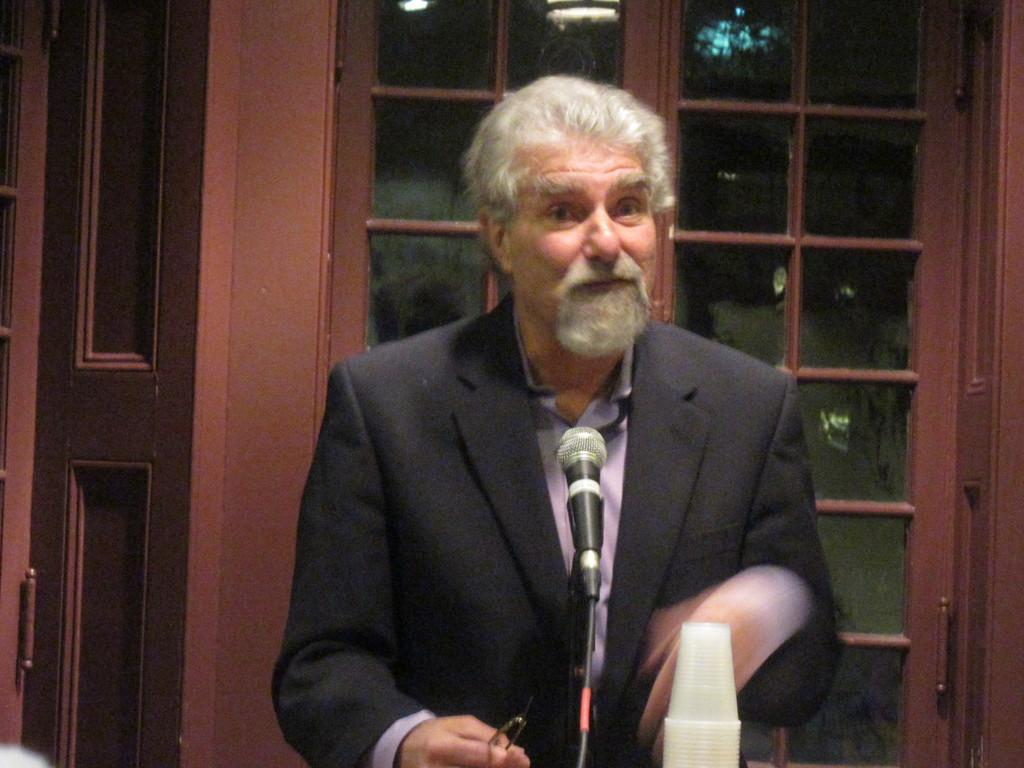Who is present in the image? There is a man in the image. What is the man doing in the image? The man is standing near a microphone. What can be seen in the background of the image? There is a window visible in the background of the image. What type of trousers is the man wearing in the image? The provided facts do not mention the type of trousers the man is wearing, so we cannot answer this question definitively. --- 